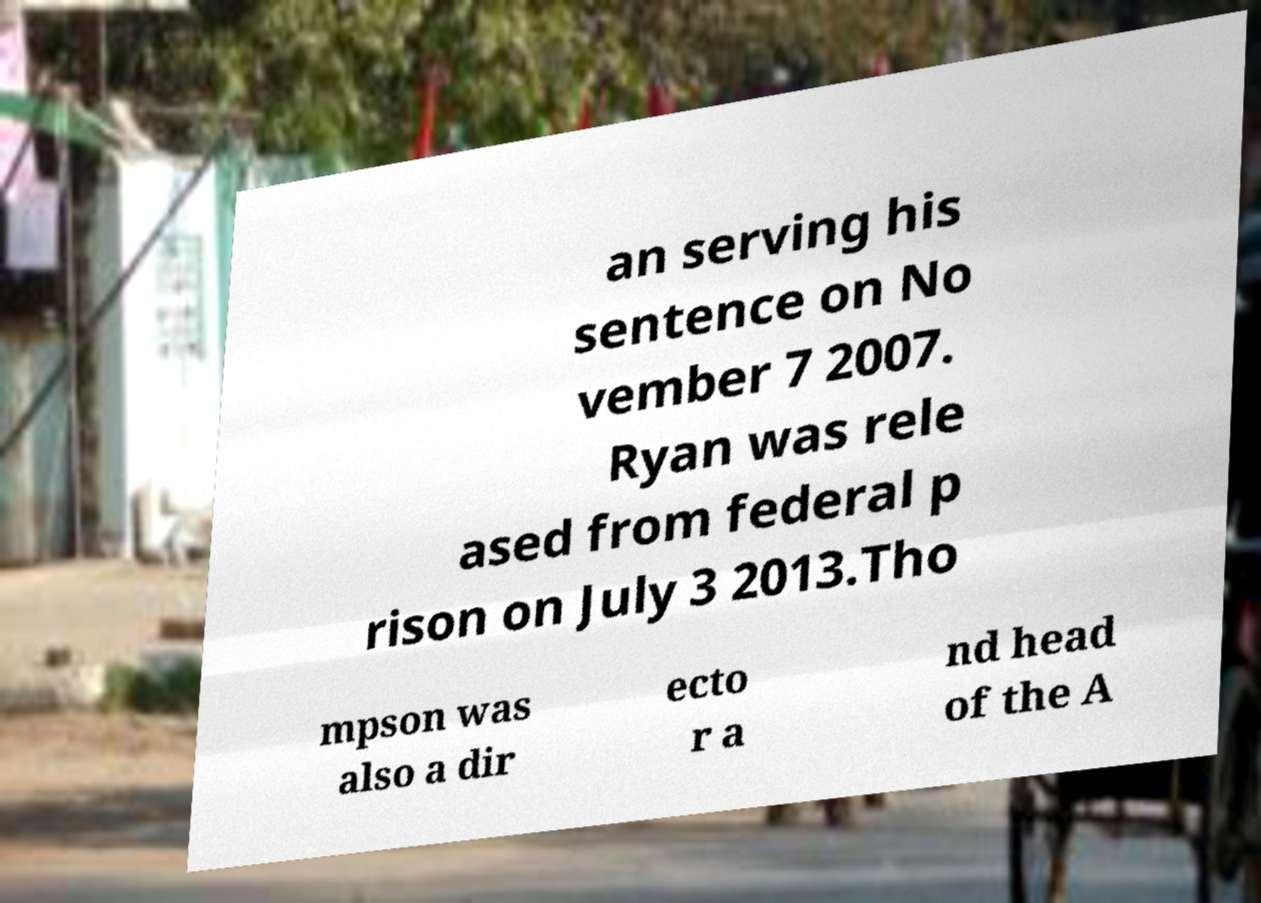Could you extract and type out the text from this image? an serving his sentence on No vember 7 2007. Ryan was rele ased from federal p rison on July 3 2013.Tho mpson was also a dir ecto r a nd head of the A 